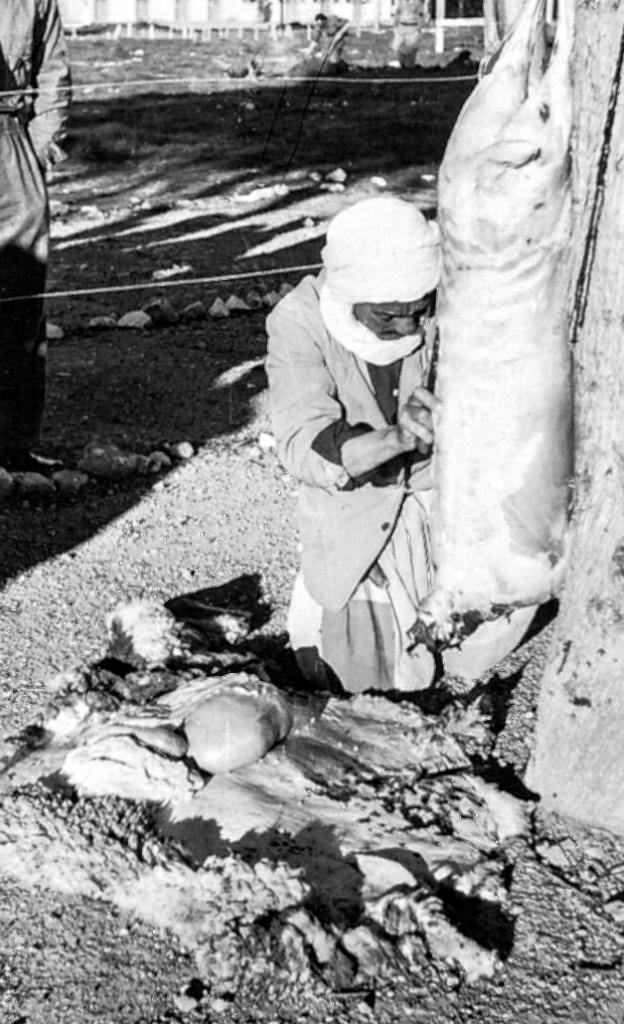Describe this image in one or two sentences. In this black and white picture there is a person kneeling on the ground. Beside him there is a dead animal hanging to the tree. In front of him there are a few objects on the ground. To the left there is a person standing. In the background there is a wall. In front of the wall there is a person standing on the ground. 